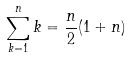Convert formula to latex. <formula><loc_0><loc_0><loc_500><loc_500>\sum _ { k = 1 } ^ { n } k = \frac { n } { 2 } ( 1 + n )</formula> 